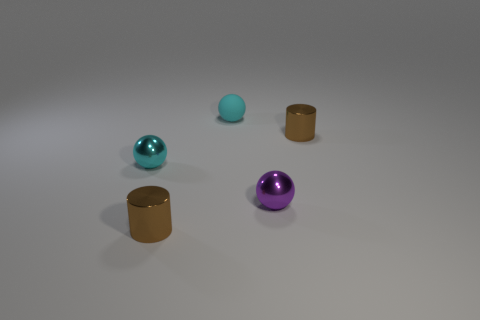Is there any other thing that is made of the same material as the tiny purple thing?
Make the answer very short. Yes. What is the size of the sphere that is the same material as the purple object?
Your response must be concise. Small. What number of big rubber things are the same color as the tiny rubber thing?
Provide a short and direct response. 0. Are there fewer spheres that are right of the tiny purple metal ball than cyan shiny things behind the cyan metallic object?
Ensure brevity in your answer.  No. There is a matte ball to the left of the purple sphere; how big is it?
Provide a short and direct response. Small. The shiny ball that is the same color as the rubber thing is what size?
Keep it short and to the point. Small. Is there a blue block that has the same material as the small purple sphere?
Keep it short and to the point. No. The other shiny sphere that is the same size as the purple metallic sphere is what color?
Offer a terse response. Cyan. How many other things are there of the same shape as the small matte thing?
Make the answer very short. 2. Does the cyan matte ball have the same size as the metal sphere on the right side of the small cyan metal object?
Your response must be concise. Yes. 